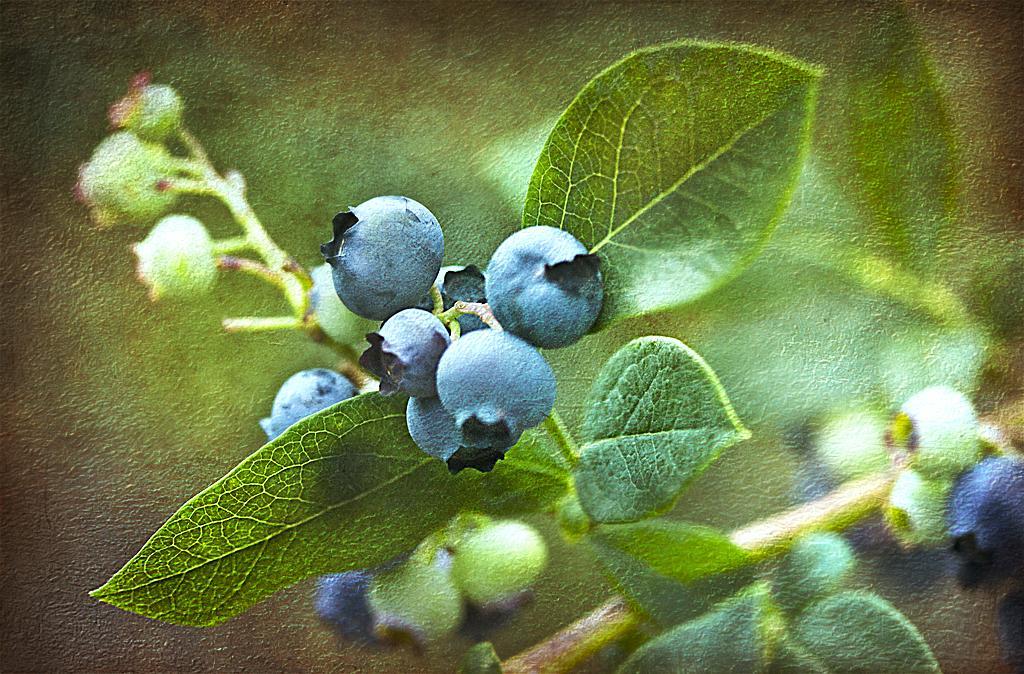Can you describe this image briefly? In this image we can see the buds, leaves and also the stems. The background is not clear. 